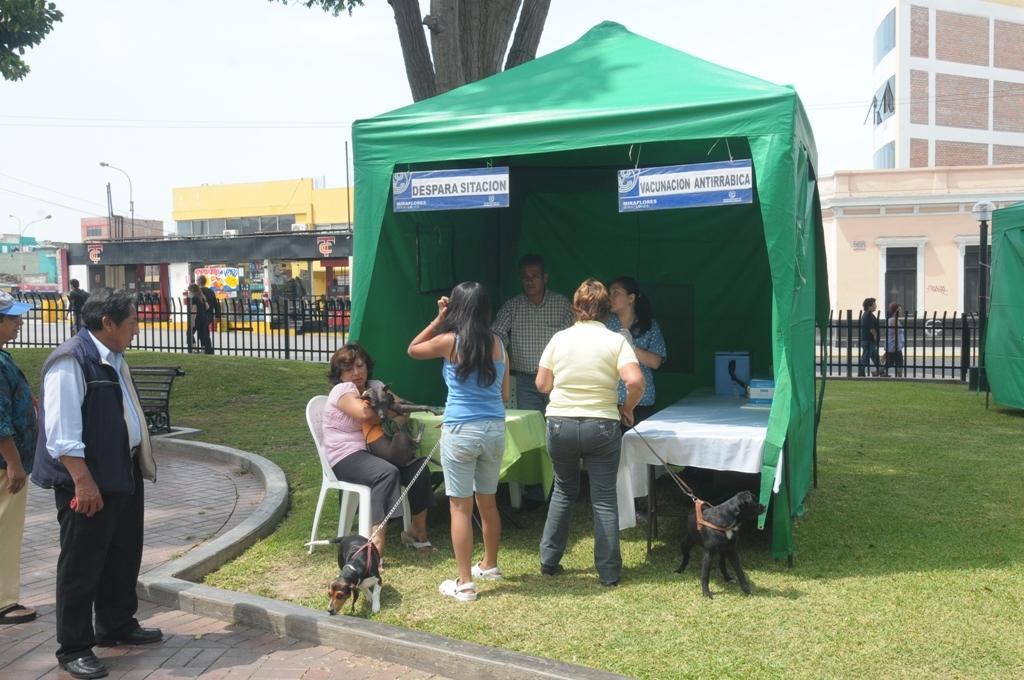Can you describe this image briefly? Here we can see a woman standing on the ground holding the dog in her hand, and her a woman sitting on the chair and holding dog in her hand, and her is the table and some objects on it, and here is the tent, and here is the tree, and here is the fencing and at above here is the sky, and here is the building. 